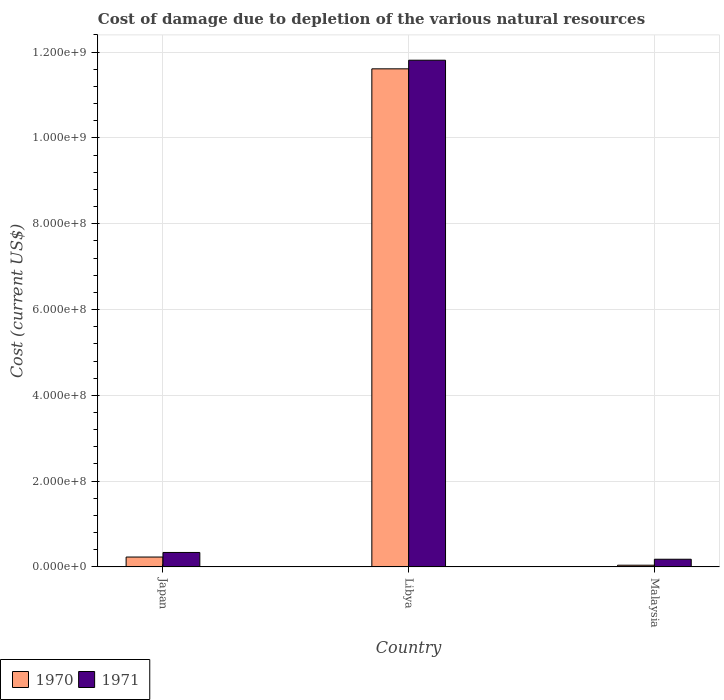How many different coloured bars are there?
Provide a short and direct response. 2. Are the number of bars on each tick of the X-axis equal?
Offer a terse response. Yes. How many bars are there on the 2nd tick from the left?
Your answer should be compact. 2. How many bars are there on the 1st tick from the right?
Your answer should be compact. 2. What is the label of the 3rd group of bars from the left?
Your answer should be very brief. Malaysia. In how many cases, is the number of bars for a given country not equal to the number of legend labels?
Your answer should be very brief. 0. What is the cost of damage caused due to the depletion of various natural resources in 1971 in Malaysia?
Keep it short and to the point. 1.79e+07. Across all countries, what is the maximum cost of damage caused due to the depletion of various natural resources in 1971?
Your answer should be very brief. 1.18e+09. Across all countries, what is the minimum cost of damage caused due to the depletion of various natural resources in 1971?
Offer a very short reply. 1.79e+07. In which country was the cost of damage caused due to the depletion of various natural resources in 1971 maximum?
Your response must be concise. Libya. In which country was the cost of damage caused due to the depletion of various natural resources in 1971 minimum?
Your response must be concise. Malaysia. What is the total cost of damage caused due to the depletion of various natural resources in 1971 in the graph?
Make the answer very short. 1.23e+09. What is the difference between the cost of damage caused due to the depletion of various natural resources in 1970 in Libya and that in Malaysia?
Your answer should be compact. 1.16e+09. What is the difference between the cost of damage caused due to the depletion of various natural resources in 1970 in Libya and the cost of damage caused due to the depletion of various natural resources in 1971 in Malaysia?
Give a very brief answer. 1.14e+09. What is the average cost of damage caused due to the depletion of various natural resources in 1971 per country?
Give a very brief answer. 4.11e+08. What is the difference between the cost of damage caused due to the depletion of various natural resources of/in 1970 and cost of damage caused due to the depletion of various natural resources of/in 1971 in Japan?
Offer a terse response. -1.07e+07. What is the ratio of the cost of damage caused due to the depletion of various natural resources in 1971 in Japan to that in Malaysia?
Provide a short and direct response. 1.88. Is the cost of damage caused due to the depletion of various natural resources in 1970 in Libya less than that in Malaysia?
Offer a very short reply. No. What is the difference between the highest and the second highest cost of damage caused due to the depletion of various natural resources in 1970?
Ensure brevity in your answer.  -1.90e+07. What is the difference between the highest and the lowest cost of damage caused due to the depletion of various natural resources in 1970?
Your response must be concise. 1.16e+09. In how many countries, is the cost of damage caused due to the depletion of various natural resources in 1970 greater than the average cost of damage caused due to the depletion of various natural resources in 1970 taken over all countries?
Offer a terse response. 1. What does the 1st bar from the left in Japan represents?
Offer a very short reply. 1970. How many bars are there?
Your response must be concise. 6. Are all the bars in the graph horizontal?
Provide a succinct answer. No. What is the difference between two consecutive major ticks on the Y-axis?
Ensure brevity in your answer.  2.00e+08. Does the graph contain grids?
Offer a terse response. Yes. What is the title of the graph?
Provide a short and direct response. Cost of damage due to depletion of the various natural resources. What is the label or title of the Y-axis?
Offer a terse response. Cost (current US$). What is the Cost (current US$) in 1970 in Japan?
Provide a short and direct response. 2.30e+07. What is the Cost (current US$) in 1971 in Japan?
Your response must be concise. 3.37e+07. What is the Cost (current US$) in 1970 in Libya?
Provide a short and direct response. 1.16e+09. What is the Cost (current US$) of 1971 in Libya?
Offer a very short reply. 1.18e+09. What is the Cost (current US$) of 1970 in Malaysia?
Ensure brevity in your answer.  3.97e+06. What is the Cost (current US$) in 1971 in Malaysia?
Give a very brief answer. 1.79e+07. Across all countries, what is the maximum Cost (current US$) in 1970?
Your answer should be compact. 1.16e+09. Across all countries, what is the maximum Cost (current US$) of 1971?
Your response must be concise. 1.18e+09. Across all countries, what is the minimum Cost (current US$) in 1970?
Your answer should be compact. 3.97e+06. Across all countries, what is the minimum Cost (current US$) in 1971?
Ensure brevity in your answer.  1.79e+07. What is the total Cost (current US$) of 1970 in the graph?
Make the answer very short. 1.19e+09. What is the total Cost (current US$) of 1971 in the graph?
Offer a very short reply. 1.23e+09. What is the difference between the Cost (current US$) of 1970 in Japan and that in Libya?
Ensure brevity in your answer.  -1.14e+09. What is the difference between the Cost (current US$) in 1971 in Japan and that in Libya?
Make the answer very short. -1.15e+09. What is the difference between the Cost (current US$) in 1970 in Japan and that in Malaysia?
Make the answer very short. 1.90e+07. What is the difference between the Cost (current US$) of 1971 in Japan and that in Malaysia?
Provide a succinct answer. 1.58e+07. What is the difference between the Cost (current US$) of 1970 in Libya and that in Malaysia?
Give a very brief answer. 1.16e+09. What is the difference between the Cost (current US$) in 1971 in Libya and that in Malaysia?
Keep it short and to the point. 1.16e+09. What is the difference between the Cost (current US$) of 1970 in Japan and the Cost (current US$) of 1971 in Libya?
Give a very brief answer. -1.16e+09. What is the difference between the Cost (current US$) of 1970 in Japan and the Cost (current US$) of 1971 in Malaysia?
Ensure brevity in your answer.  5.12e+06. What is the difference between the Cost (current US$) in 1970 in Libya and the Cost (current US$) in 1971 in Malaysia?
Provide a short and direct response. 1.14e+09. What is the average Cost (current US$) of 1970 per country?
Make the answer very short. 3.96e+08. What is the average Cost (current US$) of 1971 per country?
Your answer should be very brief. 4.11e+08. What is the difference between the Cost (current US$) in 1970 and Cost (current US$) in 1971 in Japan?
Give a very brief answer. -1.07e+07. What is the difference between the Cost (current US$) in 1970 and Cost (current US$) in 1971 in Libya?
Keep it short and to the point. -2.01e+07. What is the difference between the Cost (current US$) of 1970 and Cost (current US$) of 1971 in Malaysia?
Provide a short and direct response. -1.39e+07. What is the ratio of the Cost (current US$) in 1970 in Japan to that in Libya?
Offer a very short reply. 0.02. What is the ratio of the Cost (current US$) of 1971 in Japan to that in Libya?
Ensure brevity in your answer.  0.03. What is the ratio of the Cost (current US$) in 1970 in Japan to that in Malaysia?
Your answer should be very brief. 5.79. What is the ratio of the Cost (current US$) of 1971 in Japan to that in Malaysia?
Give a very brief answer. 1.88. What is the ratio of the Cost (current US$) of 1970 in Libya to that in Malaysia?
Give a very brief answer. 292.43. What is the ratio of the Cost (current US$) in 1971 in Libya to that in Malaysia?
Offer a terse response. 66.06. What is the difference between the highest and the second highest Cost (current US$) of 1970?
Your answer should be compact. 1.14e+09. What is the difference between the highest and the second highest Cost (current US$) in 1971?
Keep it short and to the point. 1.15e+09. What is the difference between the highest and the lowest Cost (current US$) of 1970?
Your response must be concise. 1.16e+09. What is the difference between the highest and the lowest Cost (current US$) in 1971?
Provide a succinct answer. 1.16e+09. 